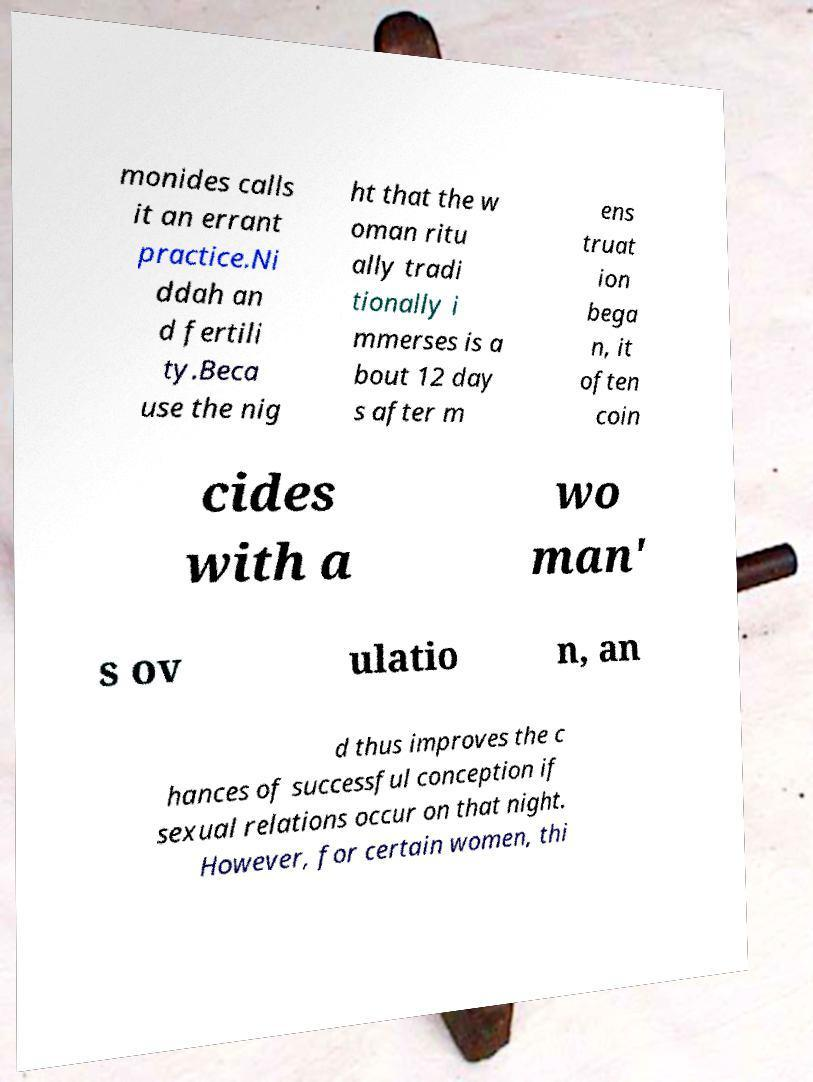I need the written content from this picture converted into text. Can you do that? monides calls it an errant practice.Ni ddah an d fertili ty.Beca use the nig ht that the w oman ritu ally tradi tionally i mmerses is a bout 12 day s after m ens truat ion bega n, it often coin cides with a wo man' s ov ulatio n, an d thus improves the c hances of successful conception if sexual relations occur on that night. However, for certain women, thi 